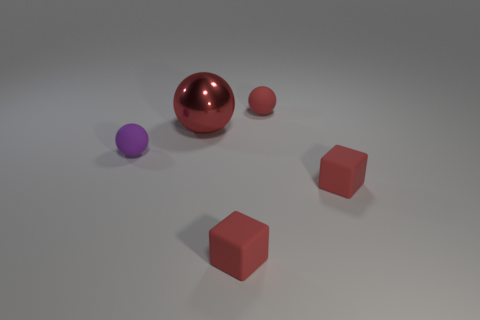Does the metallic sphere have the same color as the tiny rubber sphere right of the purple thing?
Provide a short and direct response. Yes. Are there an equal number of tiny purple rubber objects that are in front of the purple matte thing and small red blocks in front of the large thing?
Your response must be concise. No. What material is the thing that is behind the large red metallic object?
Your response must be concise. Rubber. What number of things are red objects that are behind the small purple ball or purple matte objects?
Your answer should be very brief. 3. How many other objects are there of the same shape as the large red object?
Make the answer very short. 2. There is a tiny red matte object on the right side of the red rubber ball; does it have the same shape as the metal thing?
Your answer should be compact. No. Are there any small red balls to the left of the tiny purple thing?
Keep it short and to the point. No. What number of large objects are matte balls or rubber objects?
Ensure brevity in your answer.  0. Is the large red object made of the same material as the purple object?
Give a very brief answer. No. The sphere that is the same color as the large metal object is what size?
Your response must be concise. Small. 